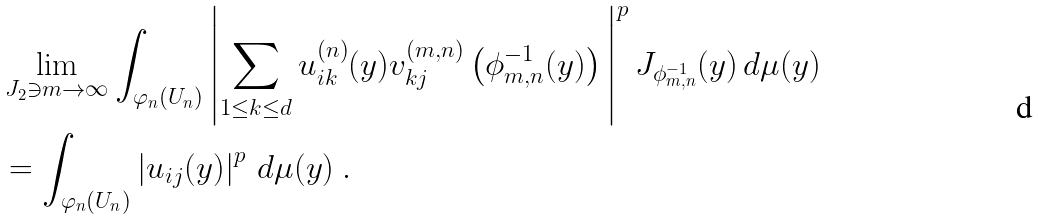<formula> <loc_0><loc_0><loc_500><loc_500>& \lim _ { J _ { 2 } \ni m \to \infty } \int _ { \varphi _ { n } ( U _ { n } ) } \left | \sum _ { 1 \leq k \leq d } u _ { i k } ^ { ( n ) } ( y ) v _ { k j } ^ { ( m , n ) } \left ( \phi _ { m , n } ^ { - 1 } ( y ) \right ) \, \right | ^ { p } J _ { \phi _ { m , n } ^ { - 1 } } ( y ) \, d \mu ( y ) \\ & = \int _ { \varphi _ { n } ( U _ { n } ) } \left | u _ { i j } ( y ) \right | ^ { p } \, d \mu ( y ) \ .</formula> 